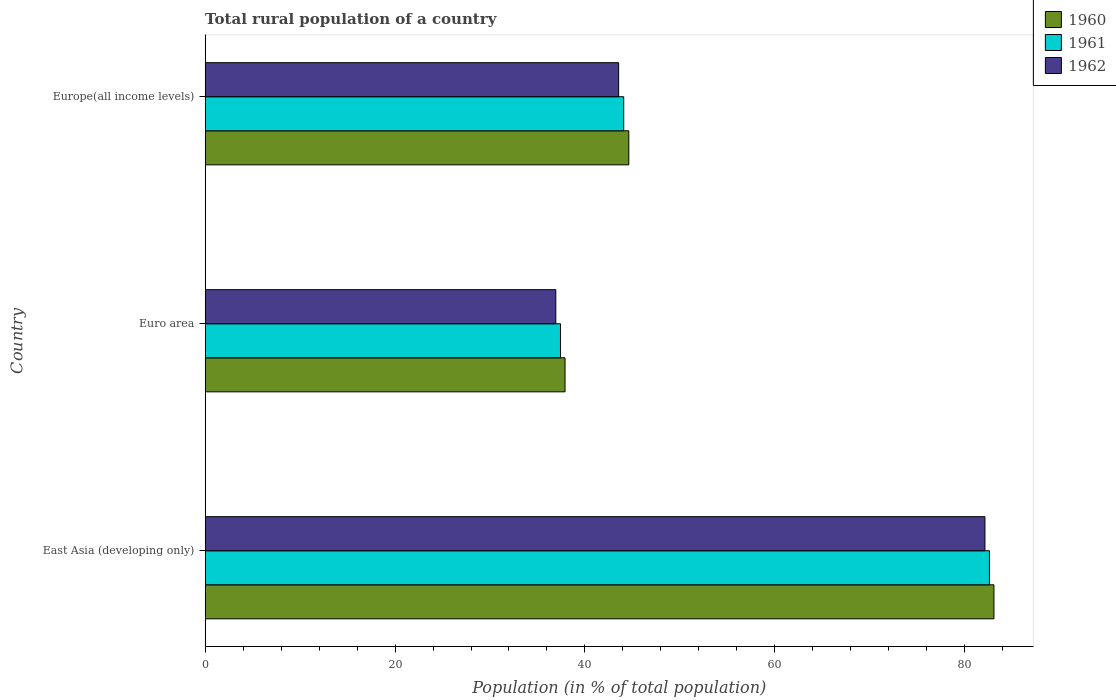How many groups of bars are there?
Your answer should be very brief. 3. Are the number of bars per tick equal to the number of legend labels?
Keep it short and to the point. Yes. Are the number of bars on each tick of the Y-axis equal?
Your response must be concise. Yes. How many bars are there on the 2nd tick from the top?
Provide a short and direct response. 3. How many bars are there on the 1st tick from the bottom?
Offer a terse response. 3. What is the rural population in 1961 in Euro area?
Provide a short and direct response. 37.42. Across all countries, what is the maximum rural population in 1962?
Make the answer very short. 82.14. Across all countries, what is the minimum rural population in 1962?
Offer a terse response. 36.93. In which country was the rural population in 1961 maximum?
Your answer should be compact. East Asia (developing only). In which country was the rural population in 1961 minimum?
Offer a terse response. Euro area. What is the total rural population in 1961 in the graph?
Offer a very short reply. 164.12. What is the difference between the rural population in 1960 in Euro area and that in Europe(all income levels)?
Provide a short and direct response. -6.72. What is the difference between the rural population in 1961 in Europe(all income levels) and the rural population in 1960 in East Asia (developing only)?
Give a very brief answer. -39. What is the average rural population in 1961 per country?
Ensure brevity in your answer.  54.71. What is the difference between the rural population in 1962 and rural population in 1961 in East Asia (developing only)?
Provide a short and direct response. -0.47. In how many countries, is the rural population in 1962 greater than 52 %?
Make the answer very short. 1. What is the ratio of the rural population in 1961 in Euro area to that in Europe(all income levels)?
Make the answer very short. 0.85. Is the rural population in 1960 in East Asia (developing only) less than that in Europe(all income levels)?
Keep it short and to the point. No. Is the difference between the rural population in 1962 in East Asia (developing only) and Europe(all income levels) greater than the difference between the rural population in 1961 in East Asia (developing only) and Europe(all income levels)?
Ensure brevity in your answer.  Yes. What is the difference between the highest and the second highest rural population in 1962?
Your answer should be very brief. 38.59. What is the difference between the highest and the lowest rural population in 1960?
Your response must be concise. 45.18. In how many countries, is the rural population in 1961 greater than the average rural population in 1961 taken over all countries?
Your response must be concise. 1. Is the sum of the rural population in 1962 in East Asia (developing only) and Euro area greater than the maximum rural population in 1960 across all countries?
Ensure brevity in your answer.  Yes. How many bars are there?
Provide a succinct answer. 9. What is the difference between two consecutive major ticks on the X-axis?
Ensure brevity in your answer.  20. Does the graph contain grids?
Ensure brevity in your answer.  No. How are the legend labels stacked?
Offer a terse response. Vertical. What is the title of the graph?
Offer a terse response. Total rural population of a country. What is the label or title of the X-axis?
Keep it short and to the point. Population (in % of total population). What is the Population (in % of total population) in 1960 in East Asia (developing only)?
Keep it short and to the point. 83.08. What is the Population (in % of total population) of 1961 in East Asia (developing only)?
Keep it short and to the point. 82.61. What is the Population (in % of total population) of 1962 in East Asia (developing only)?
Give a very brief answer. 82.14. What is the Population (in % of total population) in 1960 in Euro area?
Ensure brevity in your answer.  37.9. What is the Population (in % of total population) in 1961 in Euro area?
Provide a short and direct response. 37.42. What is the Population (in % of total population) of 1962 in Euro area?
Offer a terse response. 36.93. What is the Population (in % of total population) in 1960 in Europe(all income levels)?
Your answer should be very brief. 44.62. What is the Population (in % of total population) of 1961 in Europe(all income levels)?
Offer a terse response. 44.08. What is the Population (in % of total population) in 1962 in Europe(all income levels)?
Ensure brevity in your answer.  43.55. Across all countries, what is the maximum Population (in % of total population) of 1960?
Offer a terse response. 83.08. Across all countries, what is the maximum Population (in % of total population) in 1961?
Provide a succinct answer. 82.61. Across all countries, what is the maximum Population (in % of total population) of 1962?
Offer a terse response. 82.14. Across all countries, what is the minimum Population (in % of total population) in 1960?
Your response must be concise. 37.9. Across all countries, what is the minimum Population (in % of total population) of 1961?
Provide a short and direct response. 37.42. Across all countries, what is the minimum Population (in % of total population) of 1962?
Your answer should be very brief. 36.93. What is the total Population (in % of total population) of 1960 in the graph?
Your response must be concise. 165.61. What is the total Population (in % of total population) of 1961 in the graph?
Offer a terse response. 164.12. What is the total Population (in % of total population) of 1962 in the graph?
Offer a terse response. 162.62. What is the difference between the Population (in % of total population) in 1960 in East Asia (developing only) and that in Euro area?
Your answer should be compact. 45.18. What is the difference between the Population (in % of total population) of 1961 in East Asia (developing only) and that in Euro area?
Provide a short and direct response. 45.18. What is the difference between the Population (in % of total population) of 1962 in East Asia (developing only) and that in Euro area?
Your answer should be very brief. 45.21. What is the difference between the Population (in % of total population) of 1960 in East Asia (developing only) and that in Europe(all income levels)?
Make the answer very short. 38.46. What is the difference between the Population (in % of total population) of 1961 in East Asia (developing only) and that in Europe(all income levels)?
Offer a very short reply. 38.52. What is the difference between the Population (in % of total population) of 1962 in East Asia (developing only) and that in Europe(all income levels)?
Make the answer very short. 38.59. What is the difference between the Population (in % of total population) of 1960 in Euro area and that in Europe(all income levels)?
Keep it short and to the point. -6.72. What is the difference between the Population (in % of total population) of 1961 in Euro area and that in Europe(all income levels)?
Your response must be concise. -6.66. What is the difference between the Population (in % of total population) in 1962 in Euro area and that in Europe(all income levels)?
Offer a terse response. -6.62. What is the difference between the Population (in % of total population) of 1960 in East Asia (developing only) and the Population (in % of total population) of 1961 in Euro area?
Offer a terse response. 45.66. What is the difference between the Population (in % of total population) in 1960 in East Asia (developing only) and the Population (in % of total population) in 1962 in Euro area?
Provide a succinct answer. 46.15. What is the difference between the Population (in % of total population) in 1961 in East Asia (developing only) and the Population (in % of total population) in 1962 in Euro area?
Provide a succinct answer. 45.68. What is the difference between the Population (in % of total population) of 1960 in East Asia (developing only) and the Population (in % of total population) of 1961 in Europe(all income levels)?
Your answer should be very brief. 39. What is the difference between the Population (in % of total population) of 1960 in East Asia (developing only) and the Population (in % of total population) of 1962 in Europe(all income levels)?
Offer a very short reply. 39.53. What is the difference between the Population (in % of total population) in 1961 in East Asia (developing only) and the Population (in % of total population) in 1962 in Europe(all income levels)?
Give a very brief answer. 39.06. What is the difference between the Population (in % of total population) of 1960 in Euro area and the Population (in % of total population) of 1961 in Europe(all income levels)?
Ensure brevity in your answer.  -6.18. What is the difference between the Population (in % of total population) in 1960 in Euro area and the Population (in % of total population) in 1962 in Europe(all income levels)?
Your answer should be very brief. -5.65. What is the difference between the Population (in % of total population) of 1961 in Euro area and the Population (in % of total population) of 1962 in Europe(all income levels)?
Make the answer very short. -6.13. What is the average Population (in % of total population) in 1960 per country?
Your answer should be compact. 55.2. What is the average Population (in % of total population) in 1961 per country?
Your answer should be compact. 54.71. What is the average Population (in % of total population) in 1962 per country?
Your answer should be very brief. 54.21. What is the difference between the Population (in % of total population) in 1960 and Population (in % of total population) in 1961 in East Asia (developing only)?
Make the answer very short. 0.47. What is the difference between the Population (in % of total population) in 1960 and Population (in % of total population) in 1962 in East Asia (developing only)?
Provide a succinct answer. 0.95. What is the difference between the Population (in % of total population) in 1961 and Population (in % of total population) in 1962 in East Asia (developing only)?
Ensure brevity in your answer.  0.47. What is the difference between the Population (in % of total population) in 1960 and Population (in % of total population) in 1961 in Euro area?
Offer a terse response. 0.48. What is the difference between the Population (in % of total population) of 1960 and Population (in % of total population) of 1962 in Euro area?
Your answer should be very brief. 0.97. What is the difference between the Population (in % of total population) in 1961 and Population (in % of total population) in 1962 in Euro area?
Keep it short and to the point. 0.49. What is the difference between the Population (in % of total population) of 1960 and Population (in % of total population) of 1961 in Europe(all income levels)?
Your answer should be very brief. 0.54. What is the difference between the Population (in % of total population) of 1960 and Population (in % of total population) of 1962 in Europe(all income levels)?
Your response must be concise. 1.07. What is the difference between the Population (in % of total population) of 1961 and Population (in % of total population) of 1962 in Europe(all income levels)?
Offer a very short reply. 0.53. What is the ratio of the Population (in % of total population) of 1960 in East Asia (developing only) to that in Euro area?
Offer a terse response. 2.19. What is the ratio of the Population (in % of total population) of 1961 in East Asia (developing only) to that in Euro area?
Provide a succinct answer. 2.21. What is the ratio of the Population (in % of total population) of 1962 in East Asia (developing only) to that in Euro area?
Ensure brevity in your answer.  2.22. What is the ratio of the Population (in % of total population) in 1960 in East Asia (developing only) to that in Europe(all income levels)?
Give a very brief answer. 1.86. What is the ratio of the Population (in % of total population) in 1961 in East Asia (developing only) to that in Europe(all income levels)?
Offer a terse response. 1.87. What is the ratio of the Population (in % of total population) in 1962 in East Asia (developing only) to that in Europe(all income levels)?
Your answer should be compact. 1.89. What is the ratio of the Population (in % of total population) of 1960 in Euro area to that in Europe(all income levels)?
Ensure brevity in your answer.  0.85. What is the ratio of the Population (in % of total population) of 1961 in Euro area to that in Europe(all income levels)?
Ensure brevity in your answer.  0.85. What is the ratio of the Population (in % of total population) in 1962 in Euro area to that in Europe(all income levels)?
Ensure brevity in your answer.  0.85. What is the difference between the highest and the second highest Population (in % of total population) of 1960?
Make the answer very short. 38.46. What is the difference between the highest and the second highest Population (in % of total population) in 1961?
Provide a short and direct response. 38.52. What is the difference between the highest and the second highest Population (in % of total population) of 1962?
Offer a terse response. 38.59. What is the difference between the highest and the lowest Population (in % of total population) of 1960?
Keep it short and to the point. 45.18. What is the difference between the highest and the lowest Population (in % of total population) in 1961?
Your answer should be compact. 45.18. What is the difference between the highest and the lowest Population (in % of total population) in 1962?
Provide a short and direct response. 45.21. 